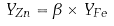<formula> <loc_0><loc_0><loc_500><loc_500>Y _ { Z n } = \beta \times Y _ { F e } \\</formula> 